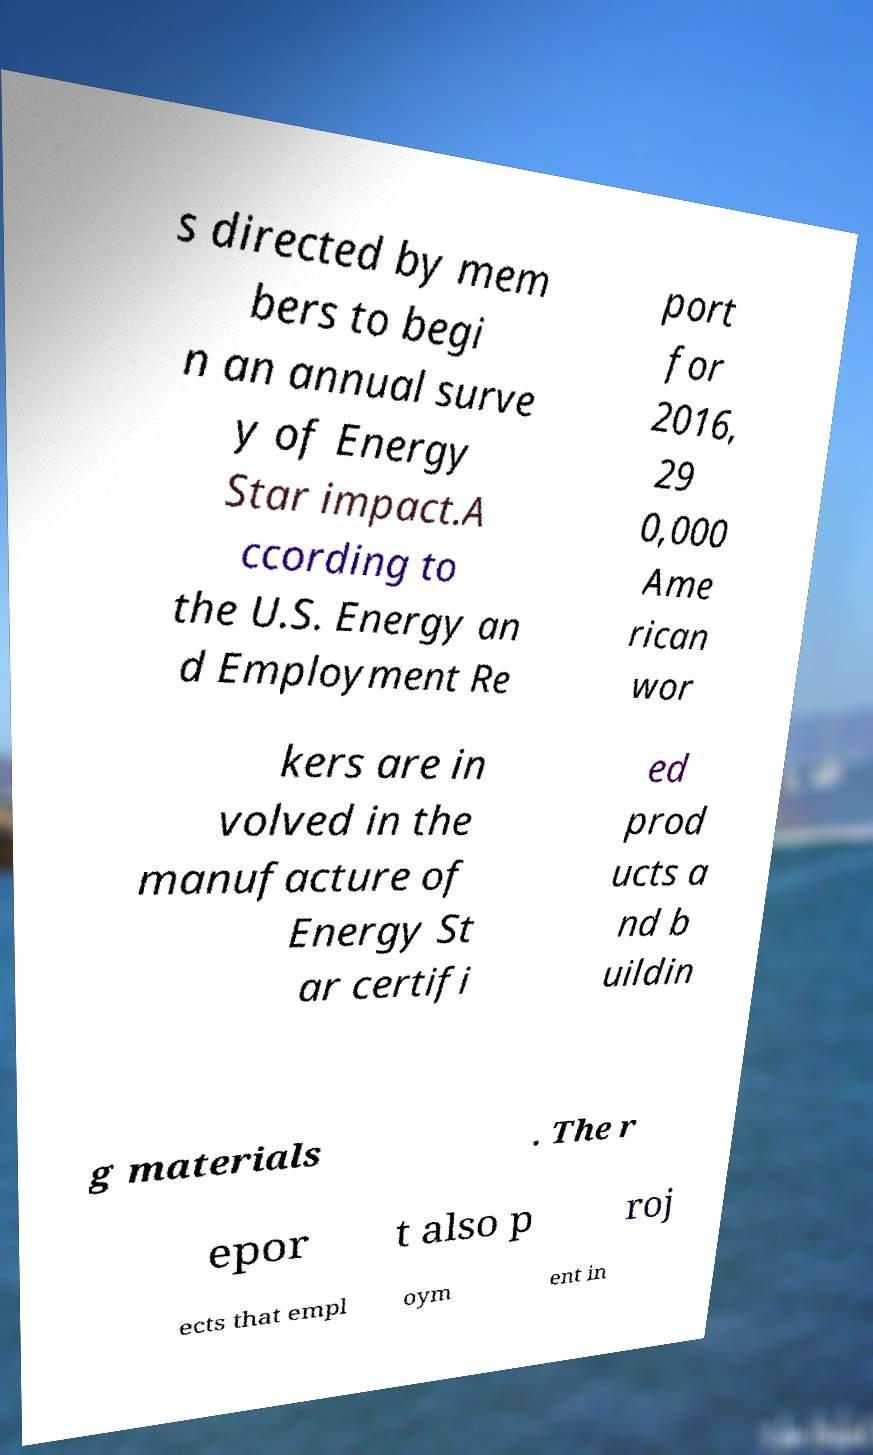Please identify and transcribe the text found in this image. s directed by mem bers to begi n an annual surve y of Energy Star impact.A ccording to the U.S. Energy an d Employment Re port for 2016, 29 0,000 Ame rican wor kers are in volved in the manufacture of Energy St ar certifi ed prod ucts a nd b uildin g materials . The r epor t also p roj ects that empl oym ent in 